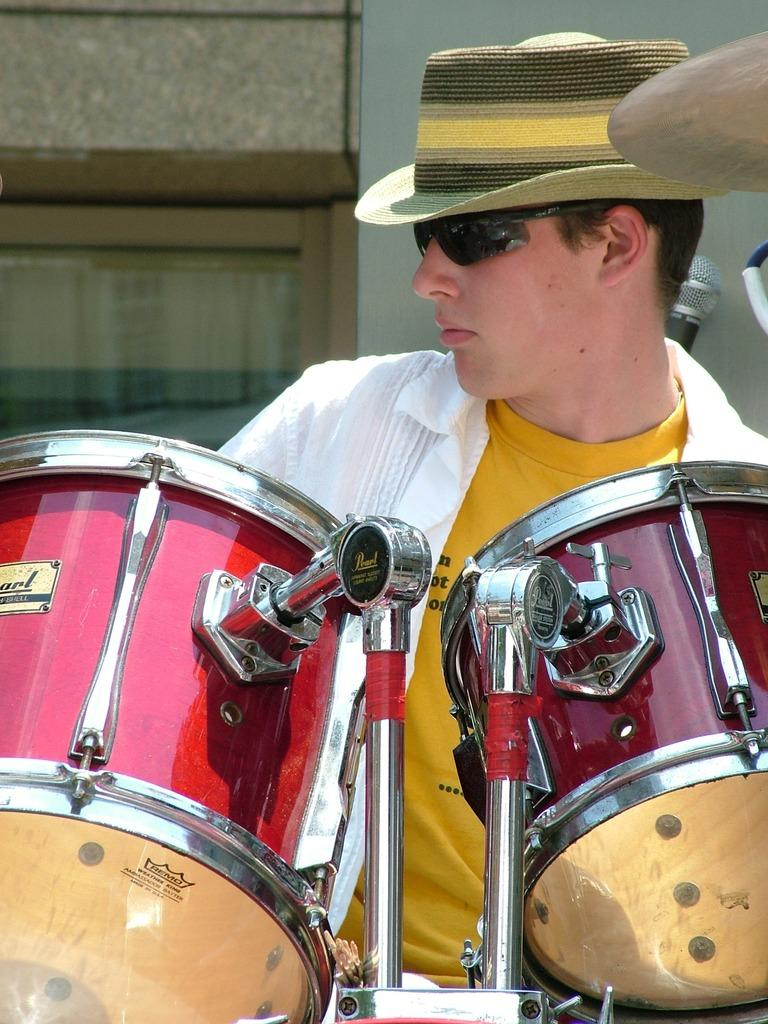Who or what is in the image? There is a person in the image. What is the person standing in front of? The person is in front of red color drums. What is the person wearing on their upper body? The person is wearing a white color shirt. What accessory is the person wearing on their face? The person is wearing spectacles. What headwear is the person wearing? The person is wearing a hat on his head. What can be seen behind the person? There is a wall in the background of the image. What type of sidewalk can be seen curving around the person in the image? There is no sidewalk present in the image, and the person is not standing near any curved structures. 